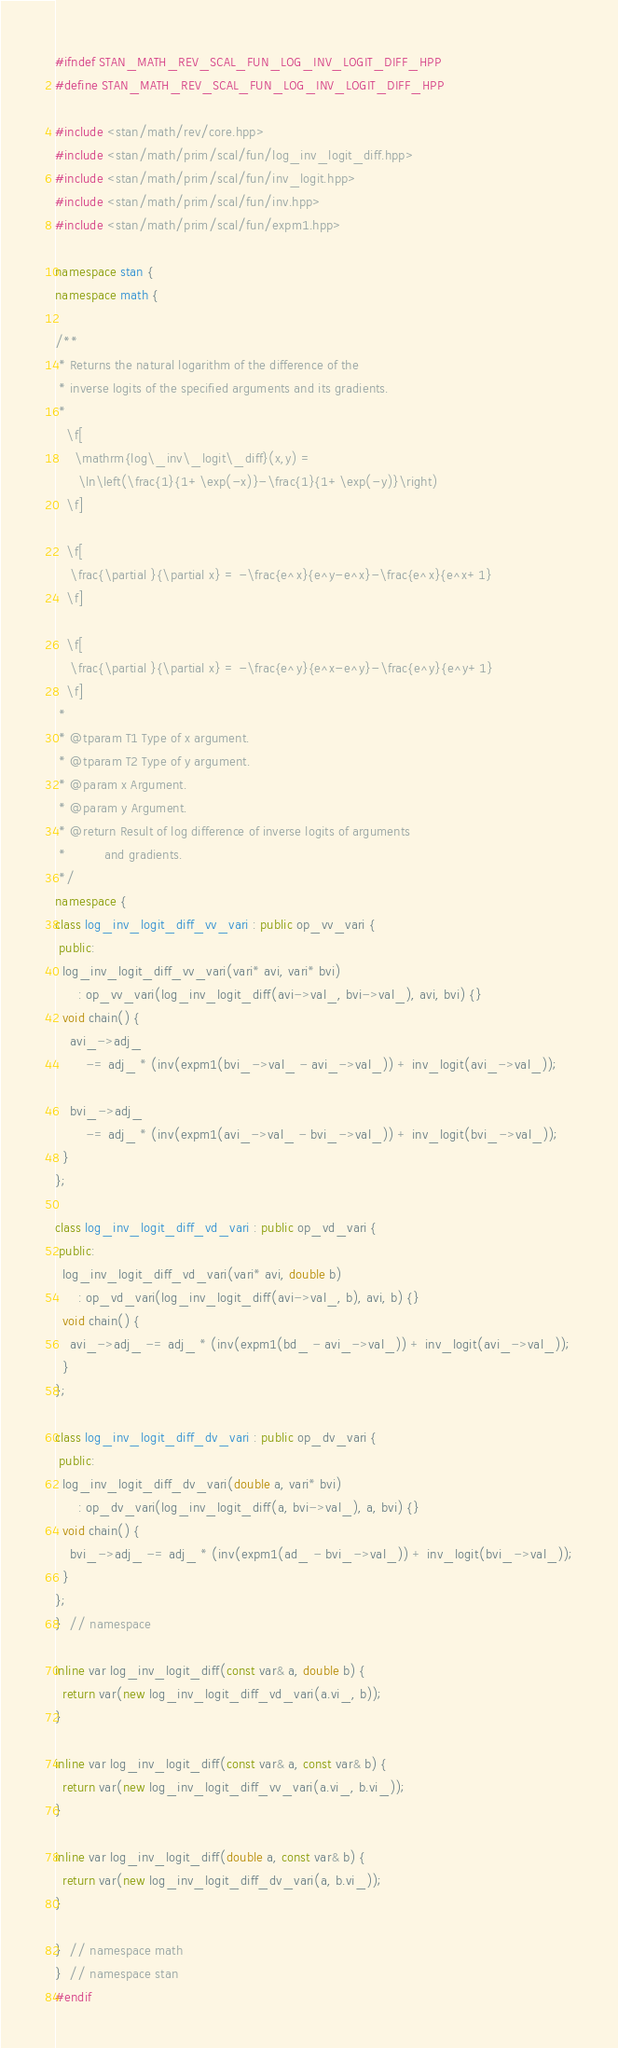Convert code to text. <code><loc_0><loc_0><loc_500><loc_500><_C++_>#ifndef STAN_MATH_REV_SCAL_FUN_LOG_INV_LOGIT_DIFF_HPP
#define STAN_MATH_REV_SCAL_FUN_LOG_INV_LOGIT_DIFF_HPP

#include <stan/math/rev/core.hpp>
#include <stan/math/prim/scal/fun/log_inv_logit_diff.hpp>
#include <stan/math/prim/scal/fun/inv_logit.hpp>
#include <stan/math/prim/scal/fun/inv.hpp>
#include <stan/math/prim/scal/fun/expm1.hpp>

namespace stan {
namespace math {

/**
 * Returns the natural logarithm of the difference of the
 * inverse logits of the specified arguments and its gradients.
 *
   \f[
     \mathrm{log\_inv\_logit\_diff}(x,y) =
      \ln\left(\frac{1}{1+\exp(-x)}-\frac{1}{1+\exp(-y)}\right)
   \f]

   \f[
    \frac{\partial }{\partial x} = -\frac{e^x}{e^y-e^x}-\frac{e^x}{e^x+1}
   \f]

   \f[
    \frac{\partial }{\partial x} = -\frac{e^y}{e^x-e^y}-\frac{e^y}{e^y+1}
   \f]
 *
 * @tparam T1 Type of x argument.
 * @tparam T2 Type of y argument.
 * @param x Argument.
 * @param y Argument.
 * @return Result of log difference of inverse logits of arguments
 *          and gradients.
 */
namespace {
class log_inv_logit_diff_vv_vari : public op_vv_vari {
 public:
  log_inv_logit_diff_vv_vari(vari* avi, vari* bvi)
      : op_vv_vari(log_inv_logit_diff(avi->val_, bvi->val_), avi, bvi) {}
  void chain() {
    avi_->adj_
        -= adj_ * (inv(expm1(bvi_->val_ - avi_->val_)) + inv_logit(avi_->val_));

    bvi_->adj_
        -= adj_ * (inv(expm1(avi_->val_ - bvi_->val_)) + inv_logit(bvi_->val_));
  }
};

class log_inv_logit_diff_vd_vari : public op_vd_vari {
 public:
  log_inv_logit_diff_vd_vari(vari* avi, double b)
      : op_vd_vari(log_inv_logit_diff(avi->val_, b), avi, b) {}
  void chain() {
    avi_->adj_ -= adj_ * (inv(expm1(bd_ - avi_->val_)) + inv_logit(avi_->val_));
  }
};

class log_inv_logit_diff_dv_vari : public op_dv_vari {
 public:
  log_inv_logit_diff_dv_vari(double a, vari* bvi)
      : op_dv_vari(log_inv_logit_diff(a, bvi->val_), a, bvi) {}
  void chain() {
    bvi_->adj_ -= adj_ * (inv(expm1(ad_ - bvi_->val_)) + inv_logit(bvi_->val_));
  }
};
}  // namespace

inline var log_inv_logit_diff(const var& a, double b) {
  return var(new log_inv_logit_diff_vd_vari(a.vi_, b));
}

inline var log_inv_logit_diff(const var& a, const var& b) {
  return var(new log_inv_logit_diff_vv_vari(a.vi_, b.vi_));
}

inline var log_inv_logit_diff(double a, const var& b) {
  return var(new log_inv_logit_diff_dv_vari(a, b.vi_));
}

}  // namespace math
}  // namespace stan
#endif
</code> 